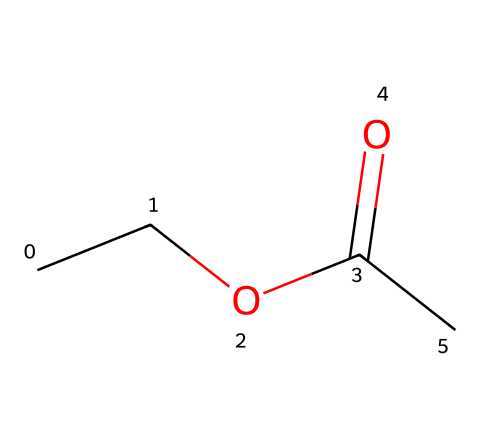What is the primary functional group in ethyl acetate? The structure exhibits a carbonyl group (C=O) adjacent to an alkoxy group (–O–), which identifies it as an ester.
Answer: ester How many carbon atoms are in ethyl acetate? By analyzing the SMILES representation, "CCOC(=O)C", we can see there are four carbon atoms connected in the structure.
Answer: 4 What is the total number of hydrogen atoms present in ethyl acetate? Each carbon typically bonds to hydrogen to complete its four bonds. Counting the hydrogens for each carbon in the structure reveals there are eight hydrogen atoms.
Answer: 8 Which type of solvent is ethyl acetate primarily classified as? Ethyl acetate is characterized as an organic solvent primarily due to its carbon-containing nature and common applications in solubilizing organic compounds.
Answer: organic What is the impact of the carbonyl group on the polarity of ethyl acetate? The polar carbonyl group increases the overall polarity of the molecule, making ethyl acetate a polar solvent, which enhances its dissolving power for certain substances.
Answer: increases How does the structure of ethyl acetate contribute to its use as an adhesive remover? The presence of the ester functional group allows ethyl acetate to effectively penetrate and break down adhesive bonds, facilitating removal.
Answer: penetrates What is the molecular weight of ethyl acetate? By calculating the molecular weight based on the number of atoms of each element present in the SMILES structure, we find that the molecular weight of ethyl acetate is 88.11 g/mol.
Answer: 88.11 